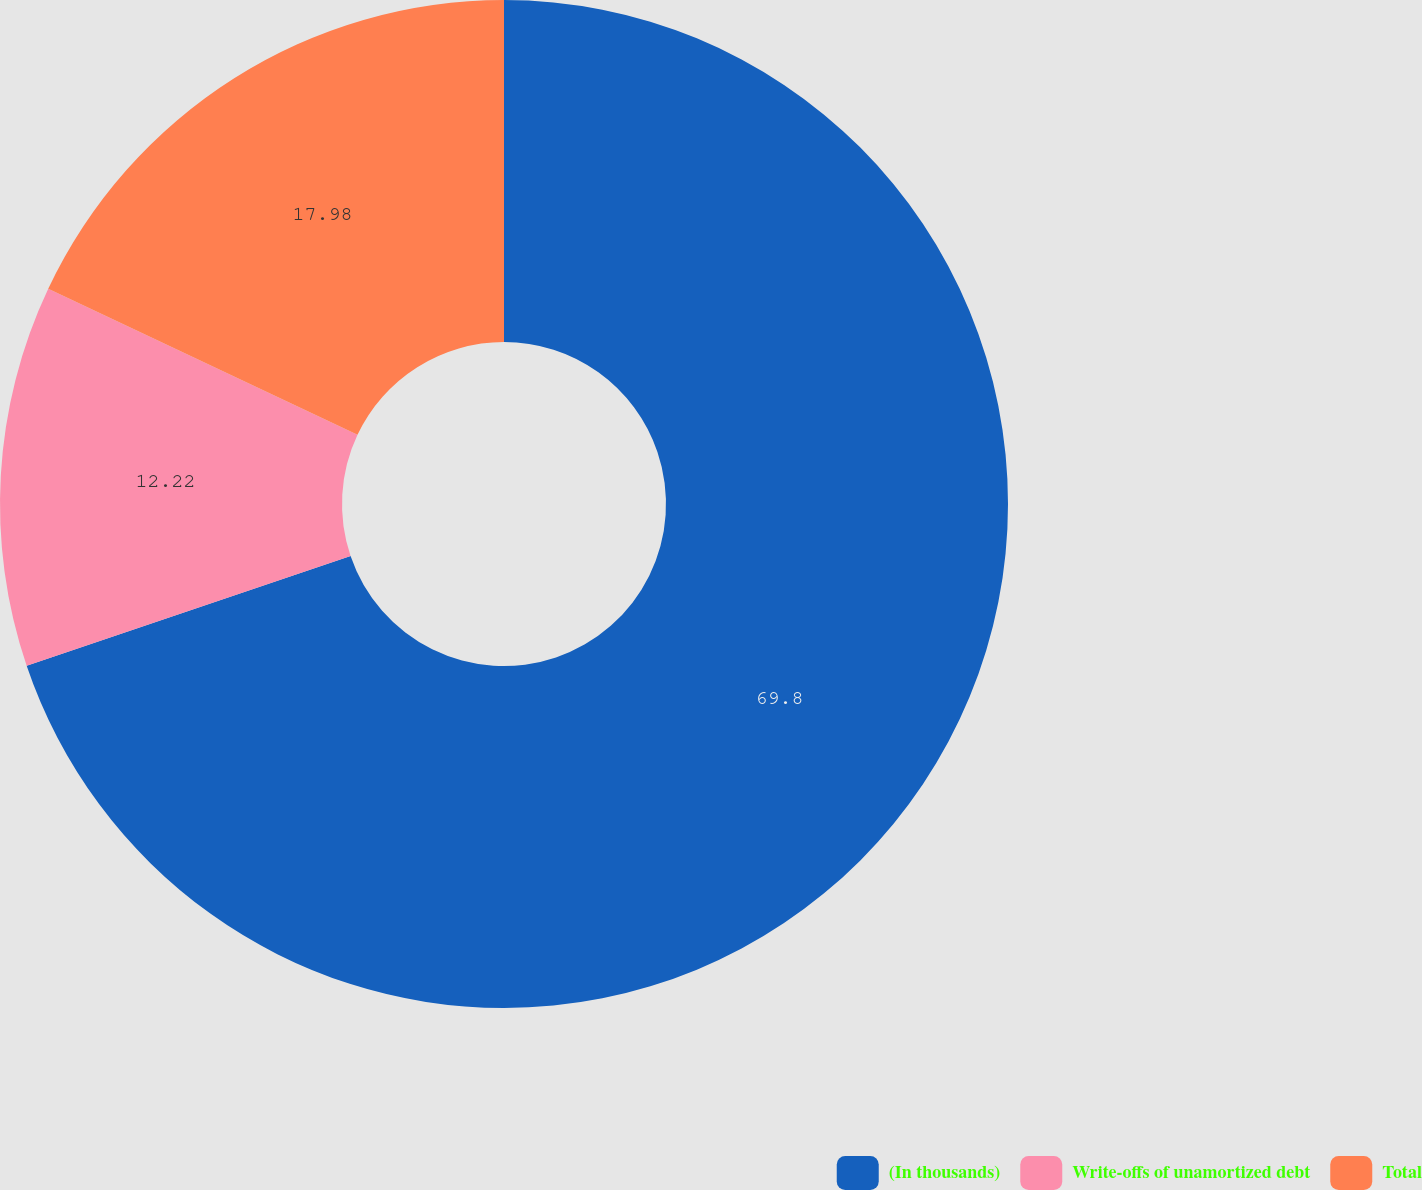Convert chart to OTSL. <chart><loc_0><loc_0><loc_500><loc_500><pie_chart><fcel>(In thousands)<fcel>Write-offs of unamortized debt<fcel>Total<nl><fcel>69.8%<fcel>12.22%<fcel>17.98%<nl></chart> 